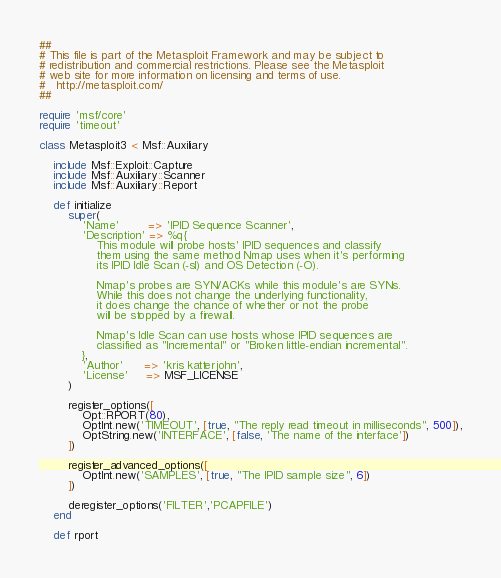<code> <loc_0><loc_0><loc_500><loc_500><_Ruby_>##
# This file is part of the Metasploit Framework and may be subject to
# redistribution and commercial restrictions. Please see the Metasploit
# web site for more information on licensing and terms of use.
#   http://metasploit.com/
##

require 'msf/core'
require 'timeout'

class Metasploit3 < Msf::Auxiliary

	include Msf::Exploit::Capture
	include Msf::Auxiliary::Scanner
	include Msf::Auxiliary::Report

	def initialize
		super(
			'Name'        => 'IPID Sequence Scanner',
			'Description' => %q{
				This module will probe hosts' IPID sequences and classify
				them using the same method Nmap uses when it's performing
				its IPID Idle Scan (-sI) and OS Detection (-O).

				Nmap's probes are SYN/ACKs while this module's are SYNs.
				While this does not change the underlying functionality,
				it does change the chance of whether or not the probe
				will be stopped by a firewall.

				Nmap's Idle Scan can use hosts whose IPID sequences are
				classified as "Incremental" or "Broken little-endian incremental".
			},
			'Author'      => 'kris katterjohn',
			'License'     => MSF_LICENSE
		)

		register_options([
			Opt::RPORT(80),
			OptInt.new('TIMEOUT', [true, "The reply read timeout in milliseconds", 500]),
			OptString.new('INTERFACE', [false, 'The name of the interface'])
		])

		register_advanced_options([
			OptInt.new('SAMPLES', [true, "The IPID sample size", 6])
		])

		deregister_options('FILTER','PCAPFILE')
	end

	def rport</code> 